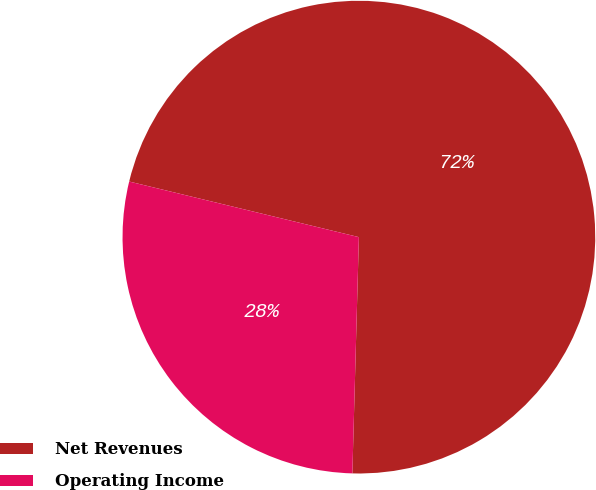<chart> <loc_0><loc_0><loc_500><loc_500><pie_chart><fcel>Net Revenues<fcel>Operating Income<nl><fcel>71.66%<fcel>28.34%<nl></chart> 